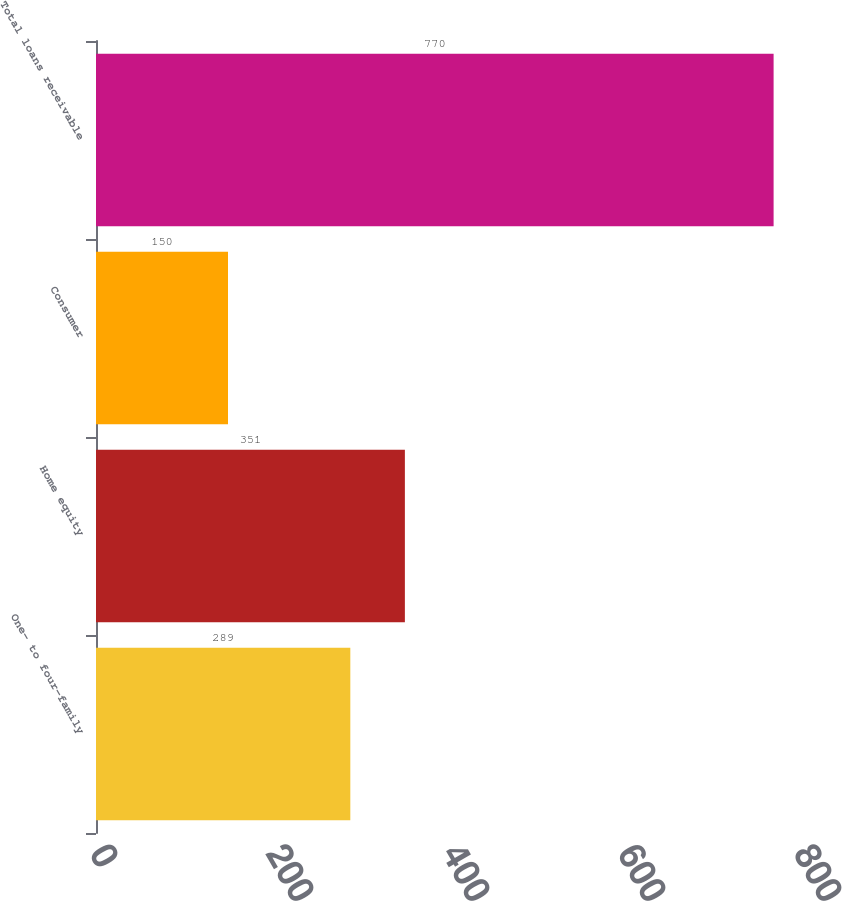Convert chart to OTSL. <chart><loc_0><loc_0><loc_500><loc_500><bar_chart><fcel>One- to four-family<fcel>Home equity<fcel>Consumer<fcel>Total loans receivable<nl><fcel>289<fcel>351<fcel>150<fcel>770<nl></chart> 